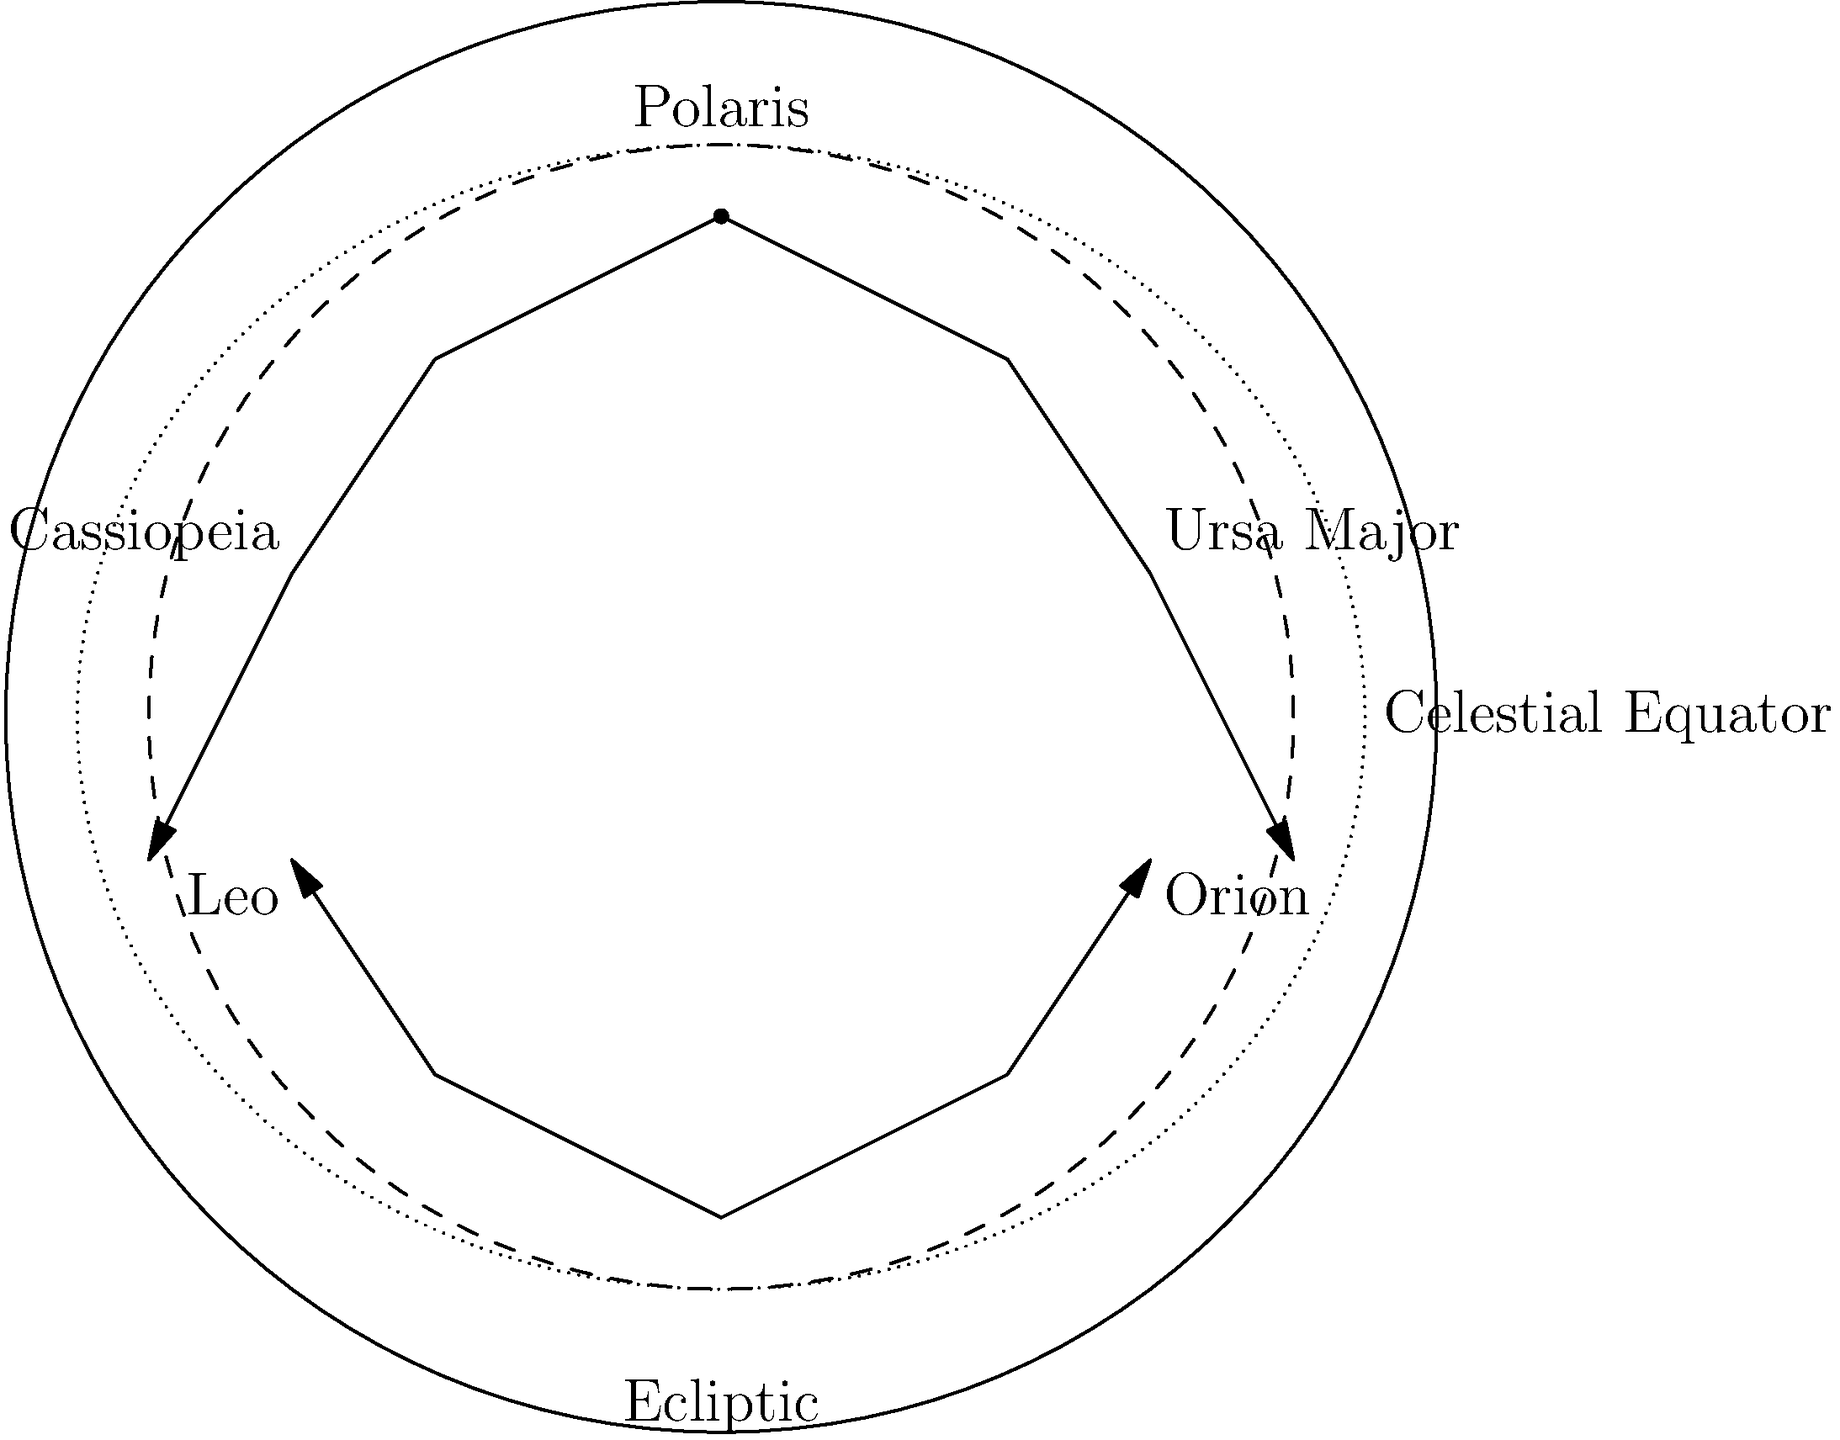As you organize your weekly meetings at the diner to discuss local initiatives, you decide to incorporate some astronomy education. Using the diagram of the night sky, which constellation would be most useful for finding true north, and how does its position relate to the other major constellations shown? To answer this question, let's analyze the diagram step-by-step:

1. The diagram shows a representation of the celestial sphere with several major constellations marked.

2. At the top of the diagram, we see a star labeled "Polaris." This is the North Star, which is always positioned almost directly above the Earth's north pole.

3. Polaris is part of the constellation Ursa Minor (the Little Dipper), though this is not explicitly labeled in the diagram.

4. To the right of Polaris, we see Ursa Major (the Big Dipper), which is a useful pointer constellation.

5. To the left of Polaris, we see Cassiopeia, which forms a distinctive W or M shape.

6. In the lower part of the diagram, we see Orion and Leo, which are prominent constellations but not as useful for finding true north.

7. Polaris is the most useful for finding true north because it remains nearly stationary in the night sky while other stars appear to rotate around it due to Earth's rotation.

8. Ursa Major and Cassiopeia are particularly helpful in locating Polaris. They are on opposite sides of Polaris and rotate around it throughout the night and seasons.

9. To find Polaris using Ursa Major, one can follow the line formed by the two stars at the front of the Big Dipper's "bowl" and extend it about 5 times the distance between those two stars.

10. Cassiopeia can also be used to find Polaris, as it forms a sort of arrow pointing towards the North Star.

Therefore, Polaris is the most useful constellation (or more accurately, star) for finding true north. Its fixed position in the night sky, along with the rotating positions of Ursa Major and Cassiopeia around it, makes it an excellent navigational tool.
Answer: Polaris (North Star), due to its fixed position above the north celestial pole. 